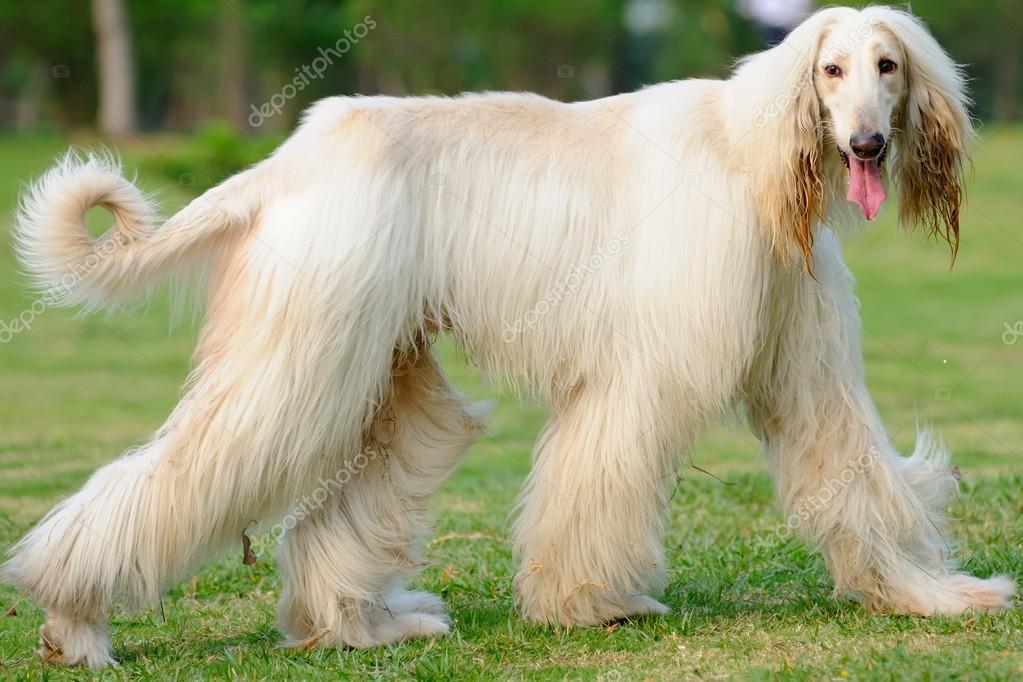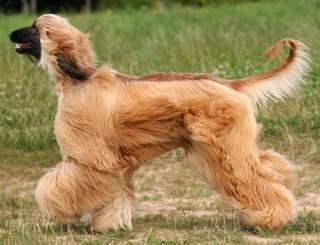The first image is the image on the left, the second image is the image on the right. Evaluate the accuracy of this statement regarding the images: "There are two dogs facing each other.". Is it true? Answer yes or no. Yes. The first image is the image on the left, the second image is the image on the right. For the images shown, is this caption "2 walking dogs have curled tails." true? Answer yes or no. Yes. 